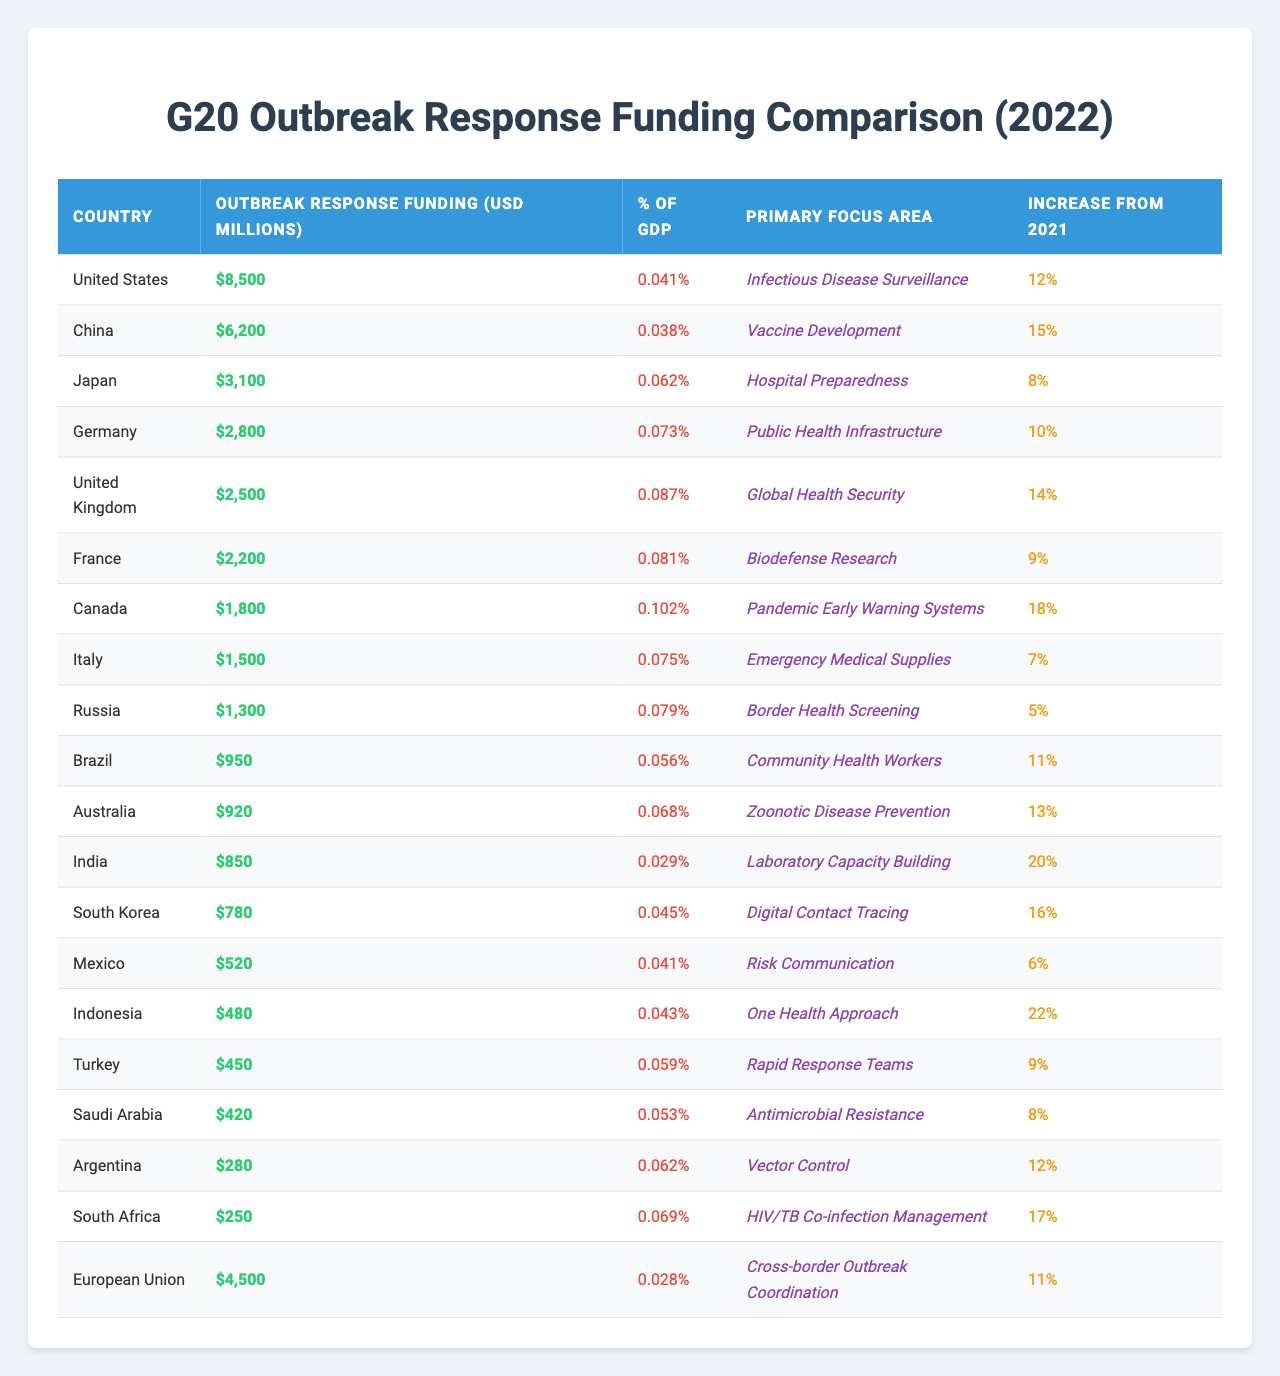What is the total outbreak response funding for all G20 countries combined in 2022? To find the total funding, sum the funding for each country listed in the table. This gives: 8500 + 6200 + 3100 + 2800 + 2500 + 2200 + 1800 + 1500 + 1300 + 950 + 920 + 850 + 780 + 520 + 480 + 450 + 420 + 280 + 250 + 4500 = 20800 million USD.
Answer: 20800 million USD Which country allocated the highest outbreak response funding in 2022? By inspecting the table, the United States has the highest funding amount at 8500 million USD.
Answer: United States Is the outbreak response funding in Brazil more than 1000 million USD? The table shows Brazil's funding as 950 million USD, which is less than 1000 million.
Answer: No What percentage of GDP does Canada allocate to outbreak response funding? According to the table, Canada has an outbreak response funding percentage of GDP equal to 0.102% (or 0.102 when expressed as a decimal).
Answer: 0.102% What is the average increase in outbreak response funding across all G20 countries from 2021 to 2022? First, convert the percentage increases to decimal values and sum them up: (0.12 + 0.15 + 0.08 + 0.10 + 0.14 + 0.09 + 0.18 + 0.07 + 0.05 + 0.11 + 0.13 + 0.20 + 0.16 + 0.06 + 0.22 + 0.09 + 0.08 + 0.12 + 0.17 + 0.11) = 2.11. There are 20 countries, so the average increase = 2.11 / 20 = 0.1055, or 10.55%.
Answer: 10.55% Which country has the lowest percentage of GDP allocated to outbreak response funding? By examining the table, the European Union allocates the lowest percentage of GDP at 0.028%.
Answer: European Union Is there a country in the G20 where the primary focus area of outbreak response is 'Digital Contact Tracing'? Looking at the table, South Korea has 'Digital Contact Tracing' listed as its primary focus area.
Answer: Yes How much more funding did the United States allocate for outbreak response than Italy in 2022? The U.S. allocated 8500 million USD and Italy 1500 million USD. Subtracting the two gives: 8500 - 1500 = 7000 million USD.
Answer: 7000 million USD Are the outbreak response funding increases for India and Canada greater than 15%? India's increase is 20% and Canada's is 18%. Both are greater than 15%.
Answer: Yes What is the total funding allocated to countries whose primary focus area is 'Public Health Infrastructure'? Only Germany has 'Public Health Infrastructure' as its focus area, and it allocated 2800 million USD. Thus, the total is 2800 million USD.
Answer: 2800 million USD Which two countries increased their outbreak response funding the most from 2021? India (20%) and Indonesia (22%) show the largest increases when looking at the table.
Answer: India and Indonesia 